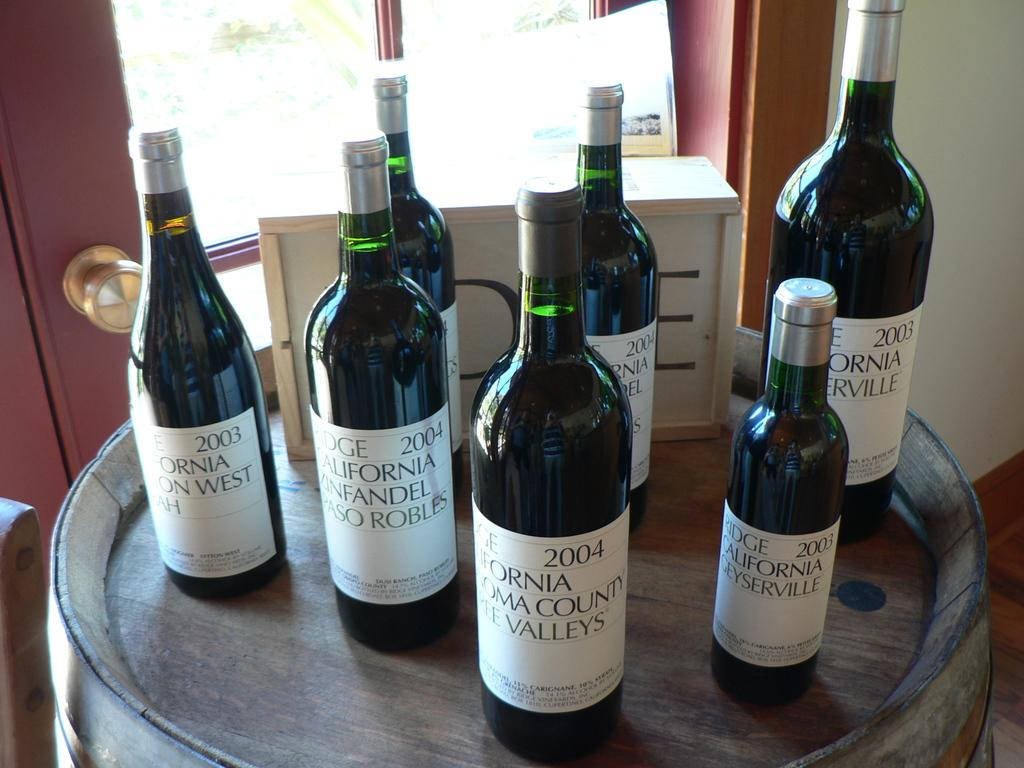What type of bottles are on the barrel in the image? There are wine bottles on the barrel in the image. What is the barrel supporting in the image? The barrel is supporting wine bottles in the image. Can you describe any other architectural features in the image? There is a door visible in the image. What type of stamp can be seen on the wine bottles in the image? There is no stamp visible on the wine bottles in the image. What kind of bird is perched on the door in the image? There is no bird, specifically a wren, present on the door in the image. 